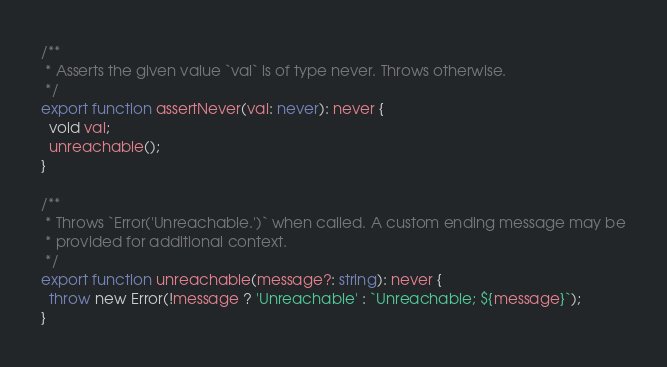<code> <loc_0><loc_0><loc_500><loc_500><_TypeScript_>/**
 * Asserts the given value `val` is of type never. Throws otherwise.
 */
export function assertNever(val: never): never {
  void val;
  unreachable();
}

/**
 * Throws `Error('Unreachable.')` when called. A custom ending message may be
 * provided for additional context.
 */
export function unreachable(message?: string): never {
  throw new Error(!message ? 'Unreachable' : `Unreachable; ${message}`);
}
</code> 